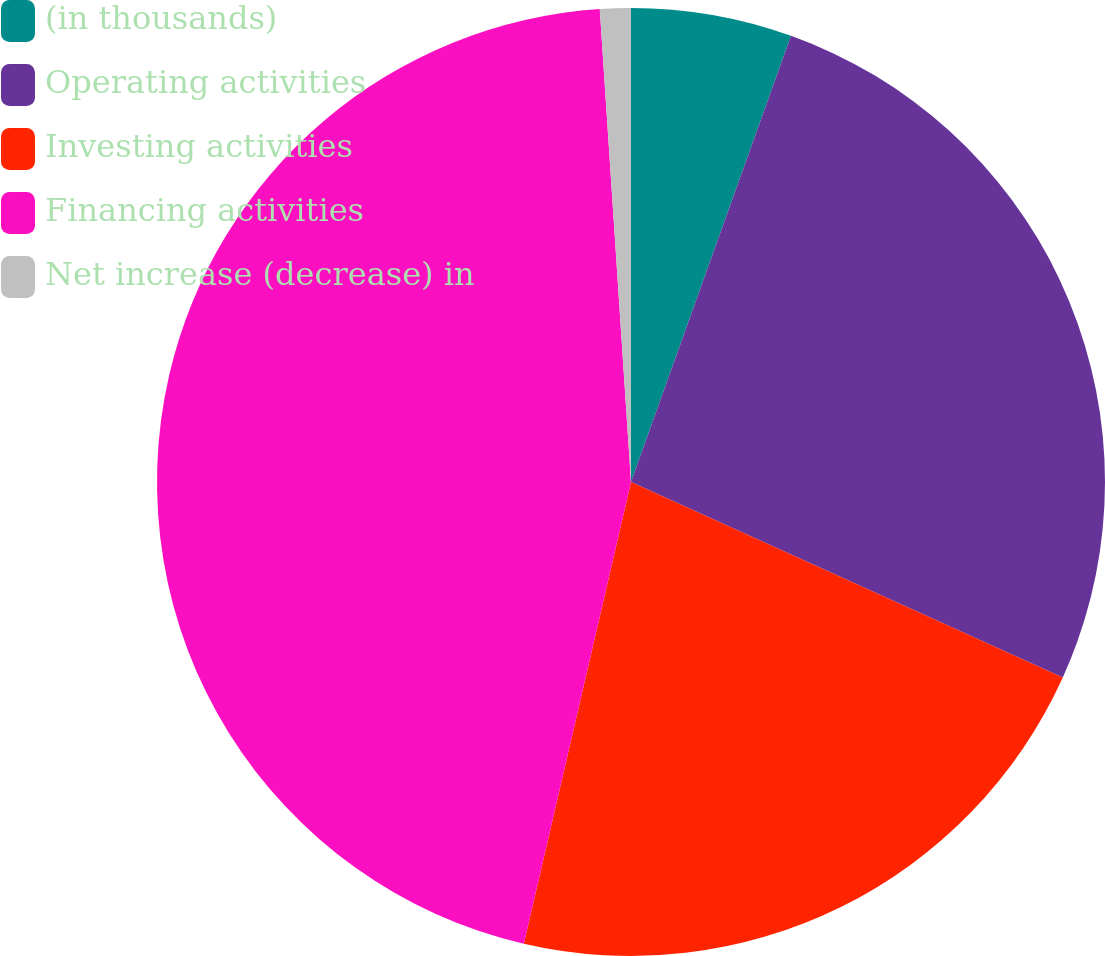<chart> <loc_0><loc_0><loc_500><loc_500><pie_chart><fcel>(in thousands)<fcel>Operating activities<fcel>Investing activities<fcel>Financing activities<fcel>Net increase (decrease) in<nl><fcel>5.48%<fcel>26.29%<fcel>21.86%<fcel>45.32%<fcel>1.05%<nl></chart> 